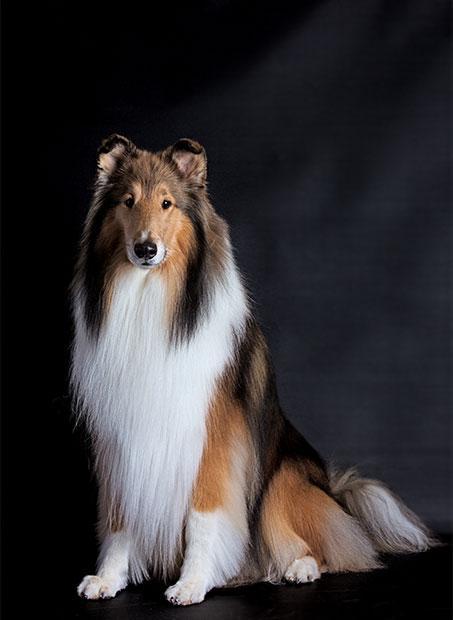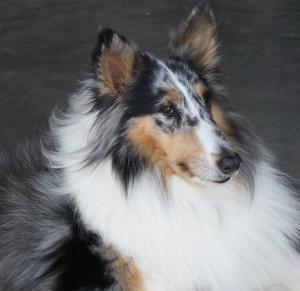The first image is the image on the left, the second image is the image on the right. For the images displayed, is the sentence "the collie on the left image is sitting with its front legs straight up." factually correct? Answer yes or no. Yes. 